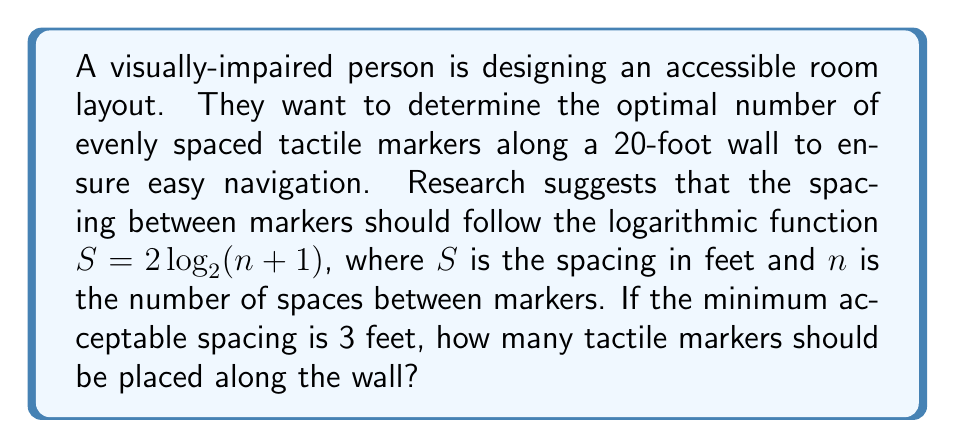Provide a solution to this math problem. Let's approach this step-by-step:

1) We know that $S = 2 \log_2(n+1)$, where $S$ is the spacing and $n$ is the number of spaces.

2) The minimum acceptable spacing is 3 feet, so we can set up the equation:

   $3 = 2 \log_2(n+1)$

3) Solve for $n$:
   
   $\frac{3}{2} = \log_2(n+1)$

4) Apply $2^x$ to both sides:

   $2^{\frac{3}{2}} = n+1$

5) Calculate:

   $2^{\frac{3}{2}} \approx 2.8284$

6) Subtract 1 from both sides:

   $n \approx 1.8284$

7) Since $n$ represents the number of spaces, and we need the number of markers, we add 1:

   Number of markers $= n + 1 \approx 2.8284$

8) We need a whole number of markers, so we round up to 3.

9) To verify, let's check if 3 markers (2 spaces) satisfy the minimum spacing requirement:

   $S = 2 \log_2(2+1) = 2 \log_2(3) \approx 3.17$ feet

10) The total length covered:
    
    $3.17 \times 2 = 6.34$ feet, which is less than the 20-foot wall length.

Therefore, 3 markers will provide optimal spacing while meeting the minimum requirement.
Answer: 3 tactile markers should be placed along the wall. 